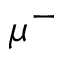Convert formula to latex. <formula><loc_0><loc_0><loc_500><loc_500>\mu ^ { - }</formula> 